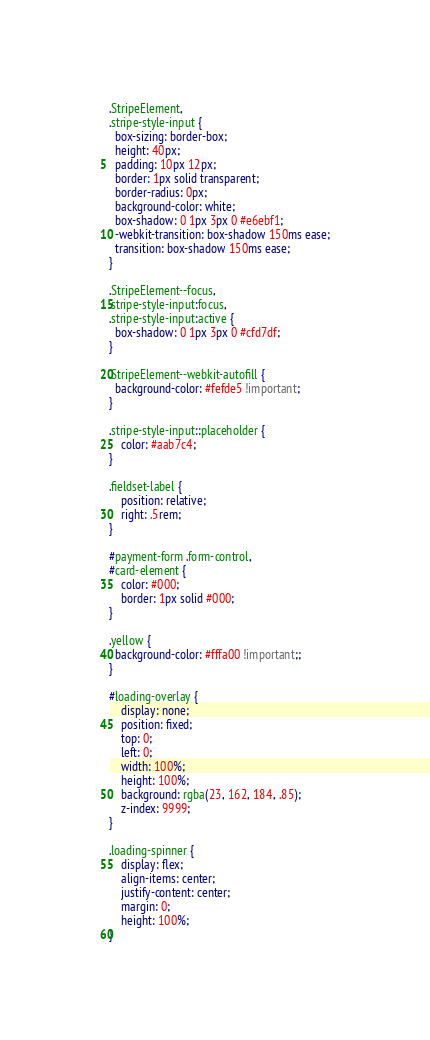Convert code to text. <code><loc_0><loc_0><loc_500><loc_500><_CSS_>.StripeElement,
.stripe-style-input {
  box-sizing: border-box;
  height: 40px;
  padding: 10px 12px;
  border: 1px solid transparent;
  border-radius: 0px;
  background-color: white;
  box-shadow: 0 1px 3px 0 #e6ebf1;
  -webkit-transition: box-shadow 150ms ease;
  transition: box-shadow 150ms ease;
}

.StripeElement--focus,
.stripe-style-input:focus,
.stripe-style-input:active {
  box-shadow: 0 1px 3px 0 #cfd7df;
}

.StripeElement--webkit-autofill {
  background-color: #fefde5 !important;
}

.stripe-style-input::placeholder {
    color: #aab7c4;
}

.fieldset-label {
    position: relative;
    right: .5rem;
}

#payment-form .form-control,
#card-element {
    color: #000;
    border: 1px solid #000;
}

.yellow {
  background-color: #fffa00 !important;;
}

#loading-overlay {
	display: none;
	position: fixed;
    top: 0;
    left: 0;
    width: 100%;
    height: 100%;
    background: rgba(23, 162, 184, .85);
    z-index: 9999;
}

.loading-spinner {
	display: flex;
    align-items: center;
    justify-content: center;
    margin: 0;
    height: 100%;
}</code> 